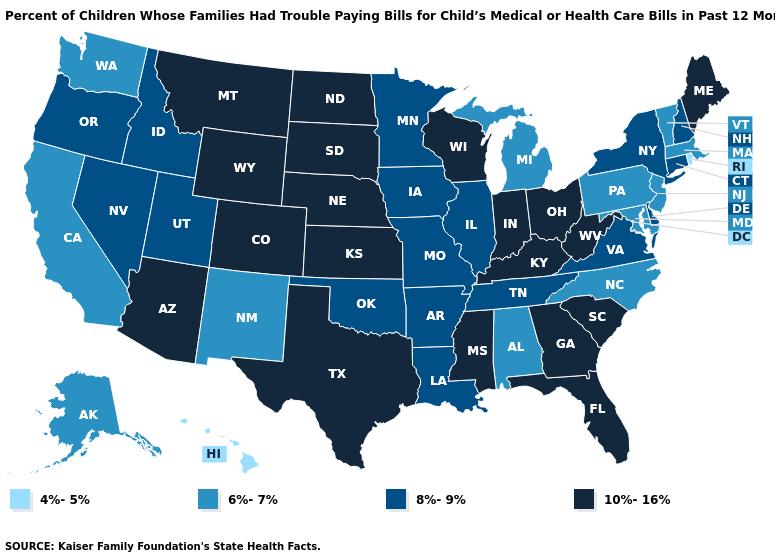Name the states that have a value in the range 4%-5%?
Write a very short answer. Hawaii, Rhode Island. Name the states that have a value in the range 6%-7%?
Short answer required. Alabama, Alaska, California, Maryland, Massachusetts, Michigan, New Jersey, New Mexico, North Carolina, Pennsylvania, Vermont, Washington. Among the states that border Rhode Island , does Massachusetts have the lowest value?
Concise answer only. Yes. What is the value of Illinois?
Answer briefly. 8%-9%. Name the states that have a value in the range 8%-9%?
Short answer required. Arkansas, Connecticut, Delaware, Idaho, Illinois, Iowa, Louisiana, Minnesota, Missouri, Nevada, New Hampshire, New York, Oklahoma, Oregon, Tennessee, Utah, Virginia. Among the states that border Vermont , which have the lowest value?
Give a very brief answer. Massachusetts. Among the states that border California , does Arizona have the lowest value?
Write a very short answer. No. Among the states that border Florida , which have the highest value?
Quick response, please. Georgia. What is the lowest value in states that border Minnesota?
Keep it brief. 8%-9%. Does Connecticut have the lowest value in the USA?
Concise answer only. No. Name the states that have a value in the range 8%-9%?
Quick response, please. Arkansas, Connecticut, Delaware, Idaho, Illinois, Iowa, Louisiana, Minnesota, Missouri, Nevada, New Hampshire, New York, Oklahoma, Oregon, Tennessee, Utah, Virginia. What is the lowest value in the Northeast?
Be succinct. 4%-5%. What is the value of North Dakota?
Quick response, please. 10%-16%. Which states have the lowest value in the West?
Short answer required. Hawaii. 